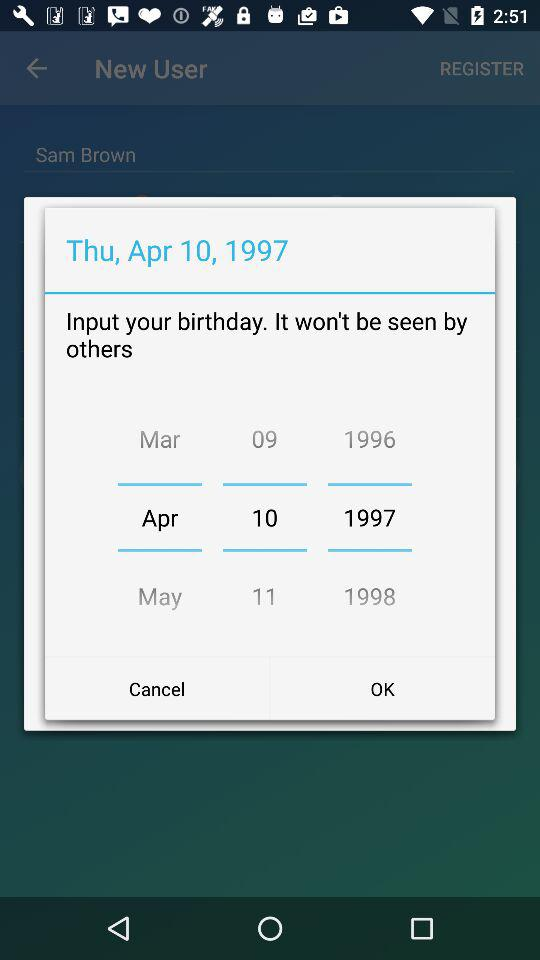What is Sam's birthday date? The birthday date is Thursday, April 10, 1997. 